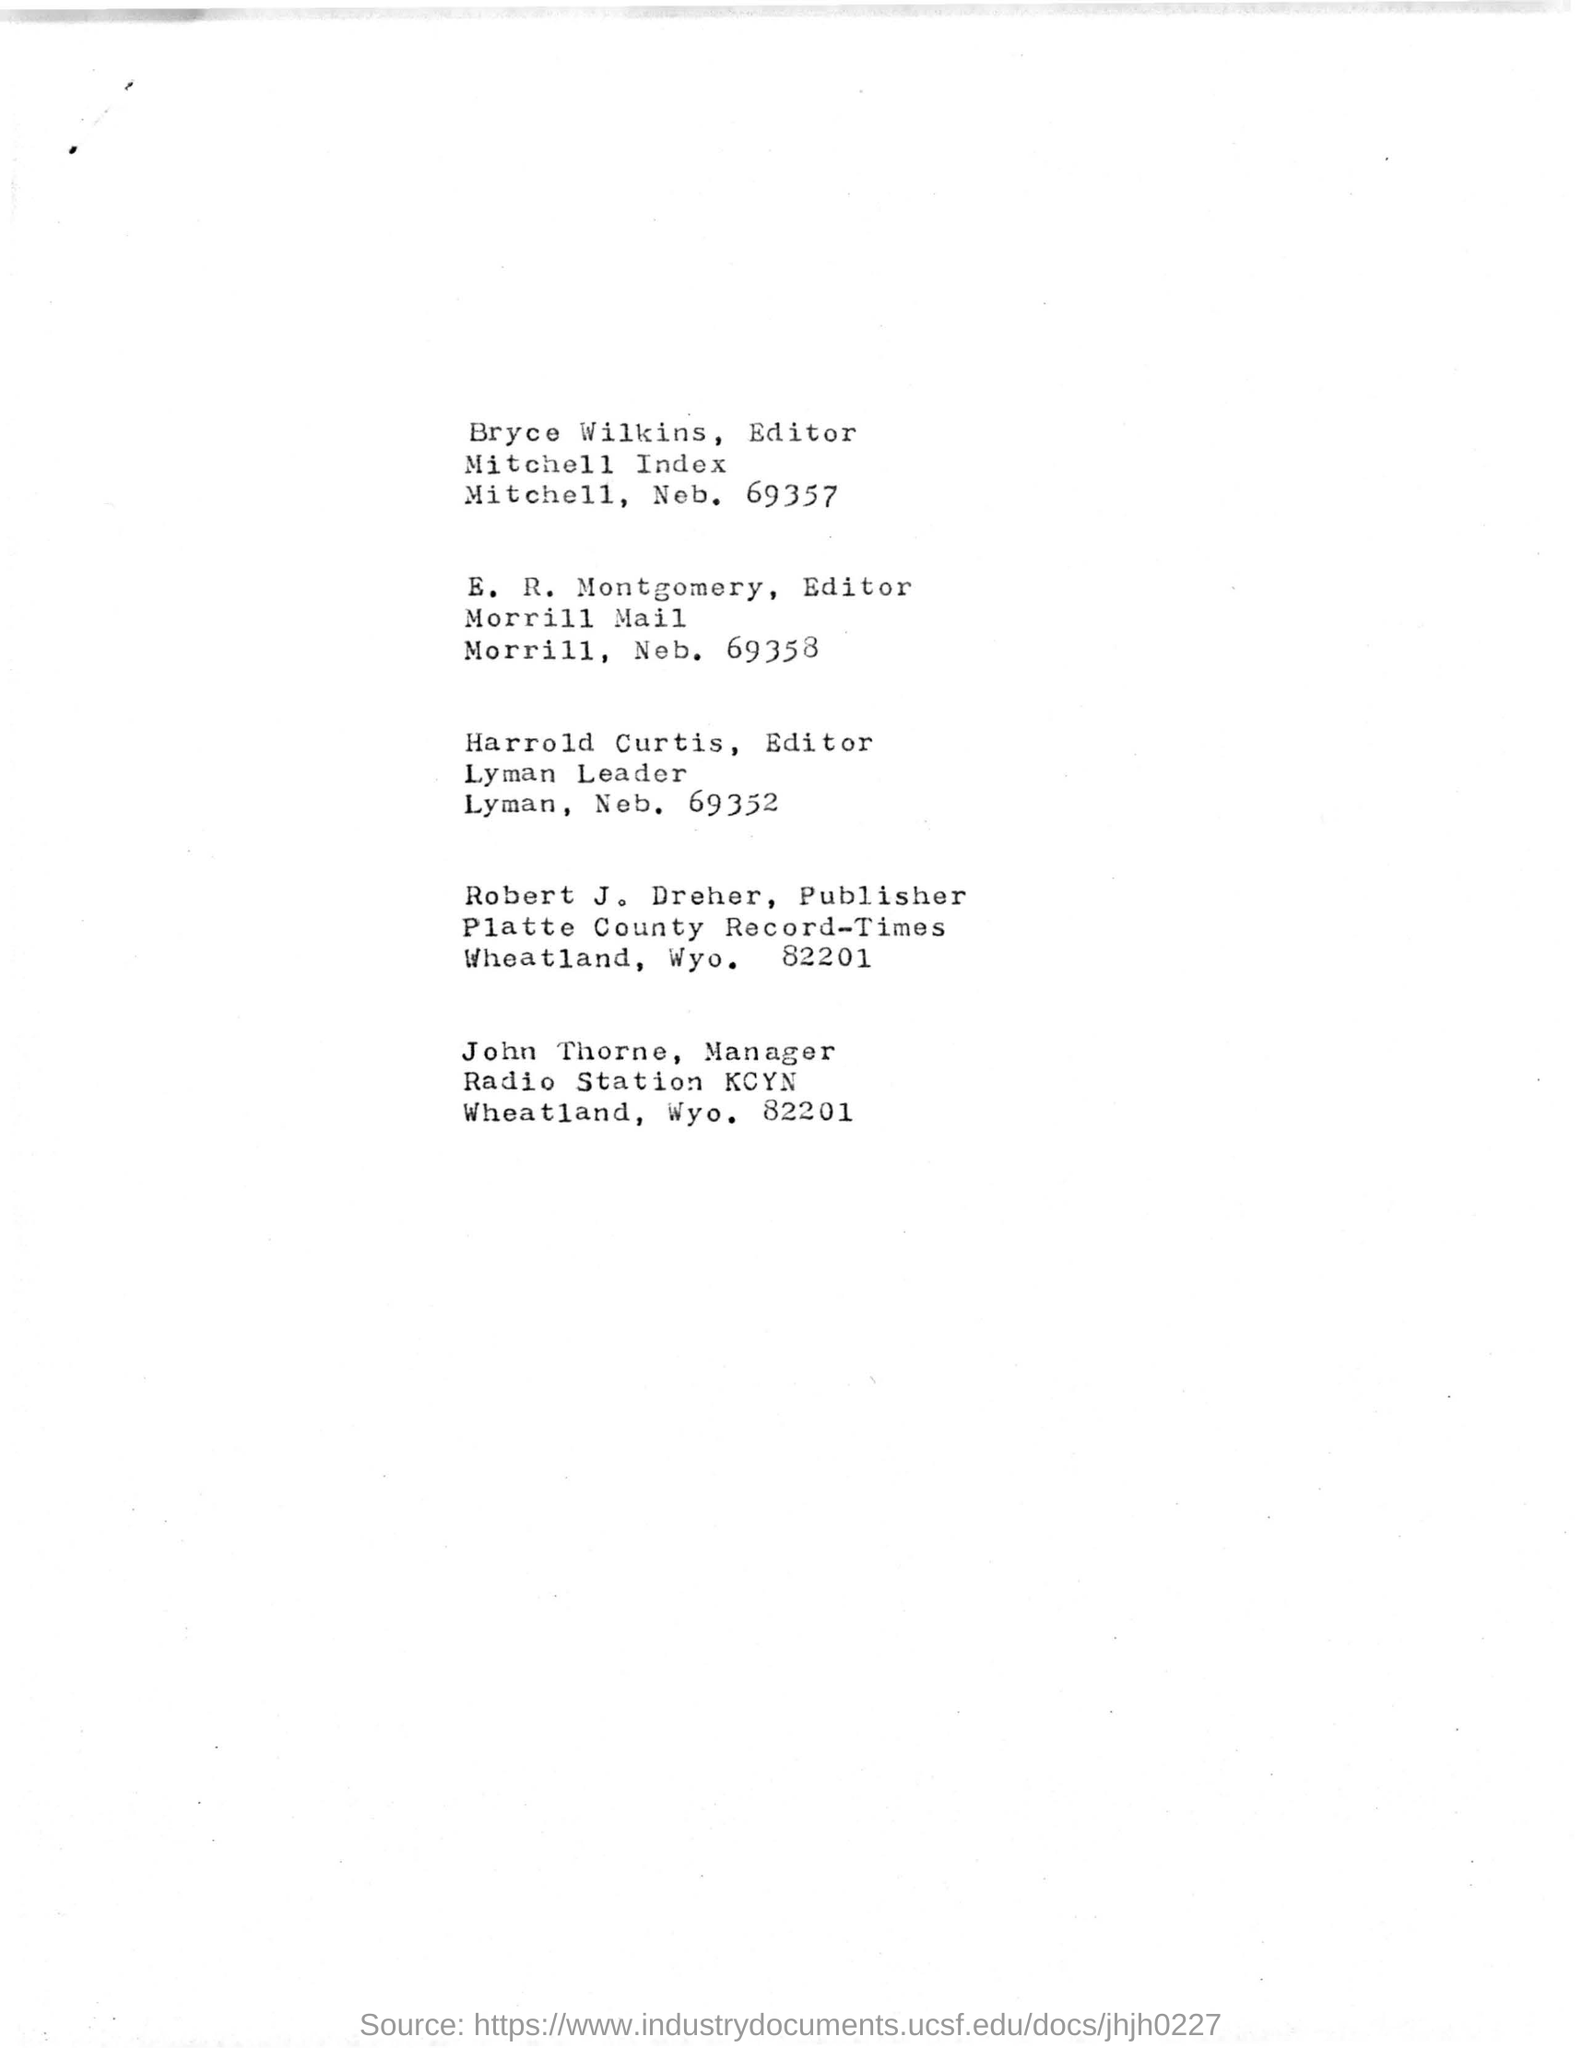Who is the editor of Mitchell Index?
Make the answer very short. Bryce Wilkins. What is the designation of E. R. Montgomery?
Provide a succinct answer. Editor Morrill Mail. Where is Platte County Record-Times?
Provide a short and direct response. Wheatland, Wyo. 